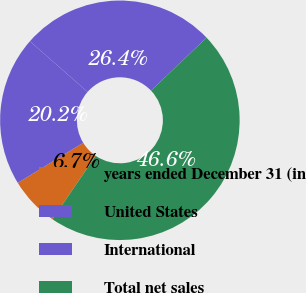Convert chart to OTSL. <chart><loc_0><loc_0><loc_500><loc_500><pie_chart><fcel>years ended December 31 (in<fcel>United States<fcel>International<fcel>Total net sales<nl><fcel>6.73%<fcel>20.22%<fcel>26.41%<fcel>46.63%<nl></chart> 